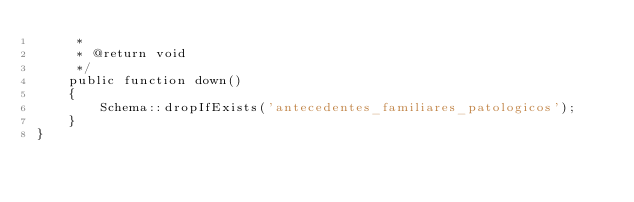Convert code to text. <code><loc_0><loc_0><loc_500><loc_500><_PHP_>     *
     * @return void
     */
    public function down()
    {
        Schema::dropIfExists('antecedentes_familiares_patologicos');
    }
}
</code> 